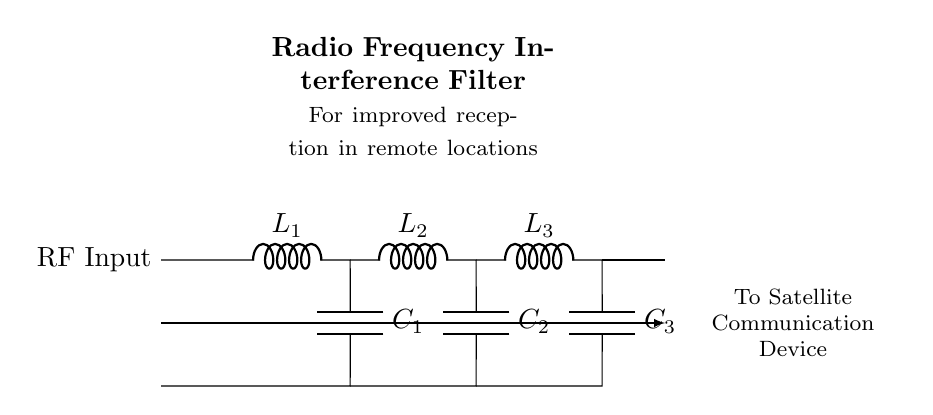What is the function of this circuit? The circuit is a Radio Frequency Interference Filter designed to improve reception for satellite communication devices, specifically in remote areas.
Answer: Radio Frequency Interference Filter How many inductors are present in the circuit? There are three inductors labeled L1, L2, and L3. Each inductor is connected in series, which contributes to the filtering function of the circuit.
Answer: Three What is the main purpose of capacitors in this filter? Capacitors in this filter are used to shunt unwanted RF frequencies to ground, thereby enhancing the circuit's ability to select desired frequencies for better satellite reception.
Answer: Shunt unwanted frequencies What is the expected input to this circuit? The expected input is RF (Radio Frequency) signal, which is indicated at the left side labeled as RF Input. This signal is the source of the information to be filtered.
Answer: RF Input What is the role of the series connection of components in the circuit? The series connection of the inductors and capacitors creates a low-pass filter effect, allowing desired signals to pass while attenuating higher frequency interference, essential for improving satellite communication.
Answer: Create low-pass filter effect Which component comes last in the signal path? The last component in the signal path is the third inductor labeled L3, which is positioned before the output to the satellite communication device.
Answer: L3 